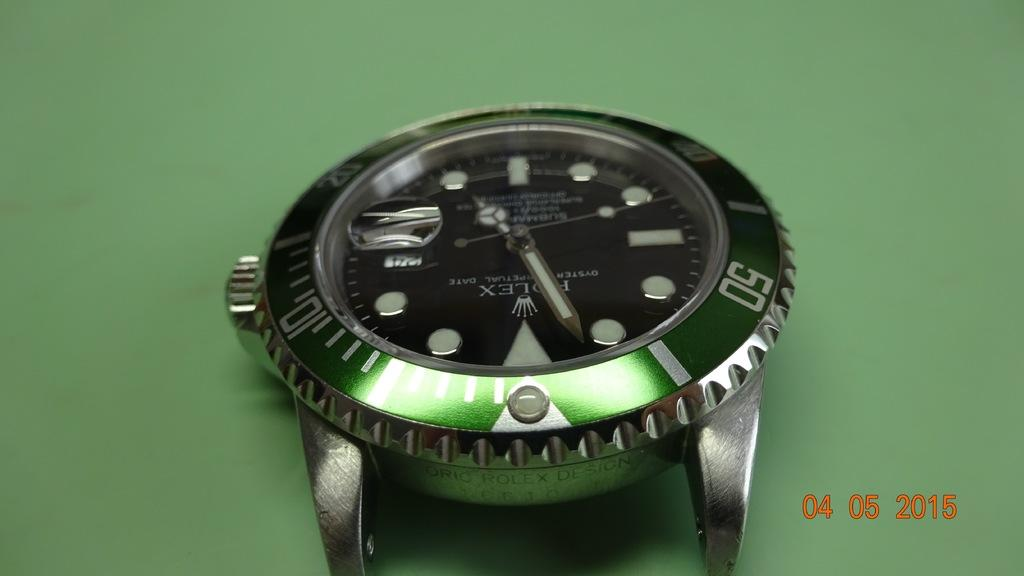<image>
Render a clear and concise summary of the photo. Face of a watch which says the word ROLEX on it. 